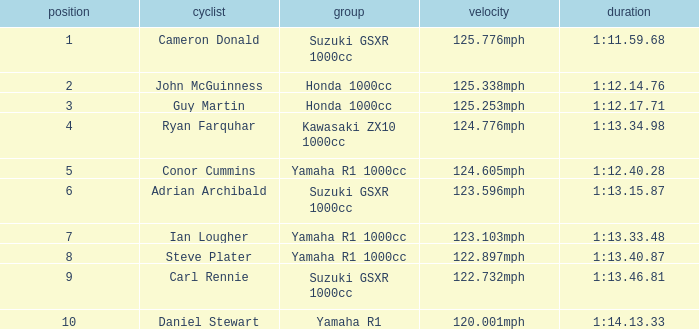What is the rank for the team with a Time of 1:12.40.28? 5.0. 